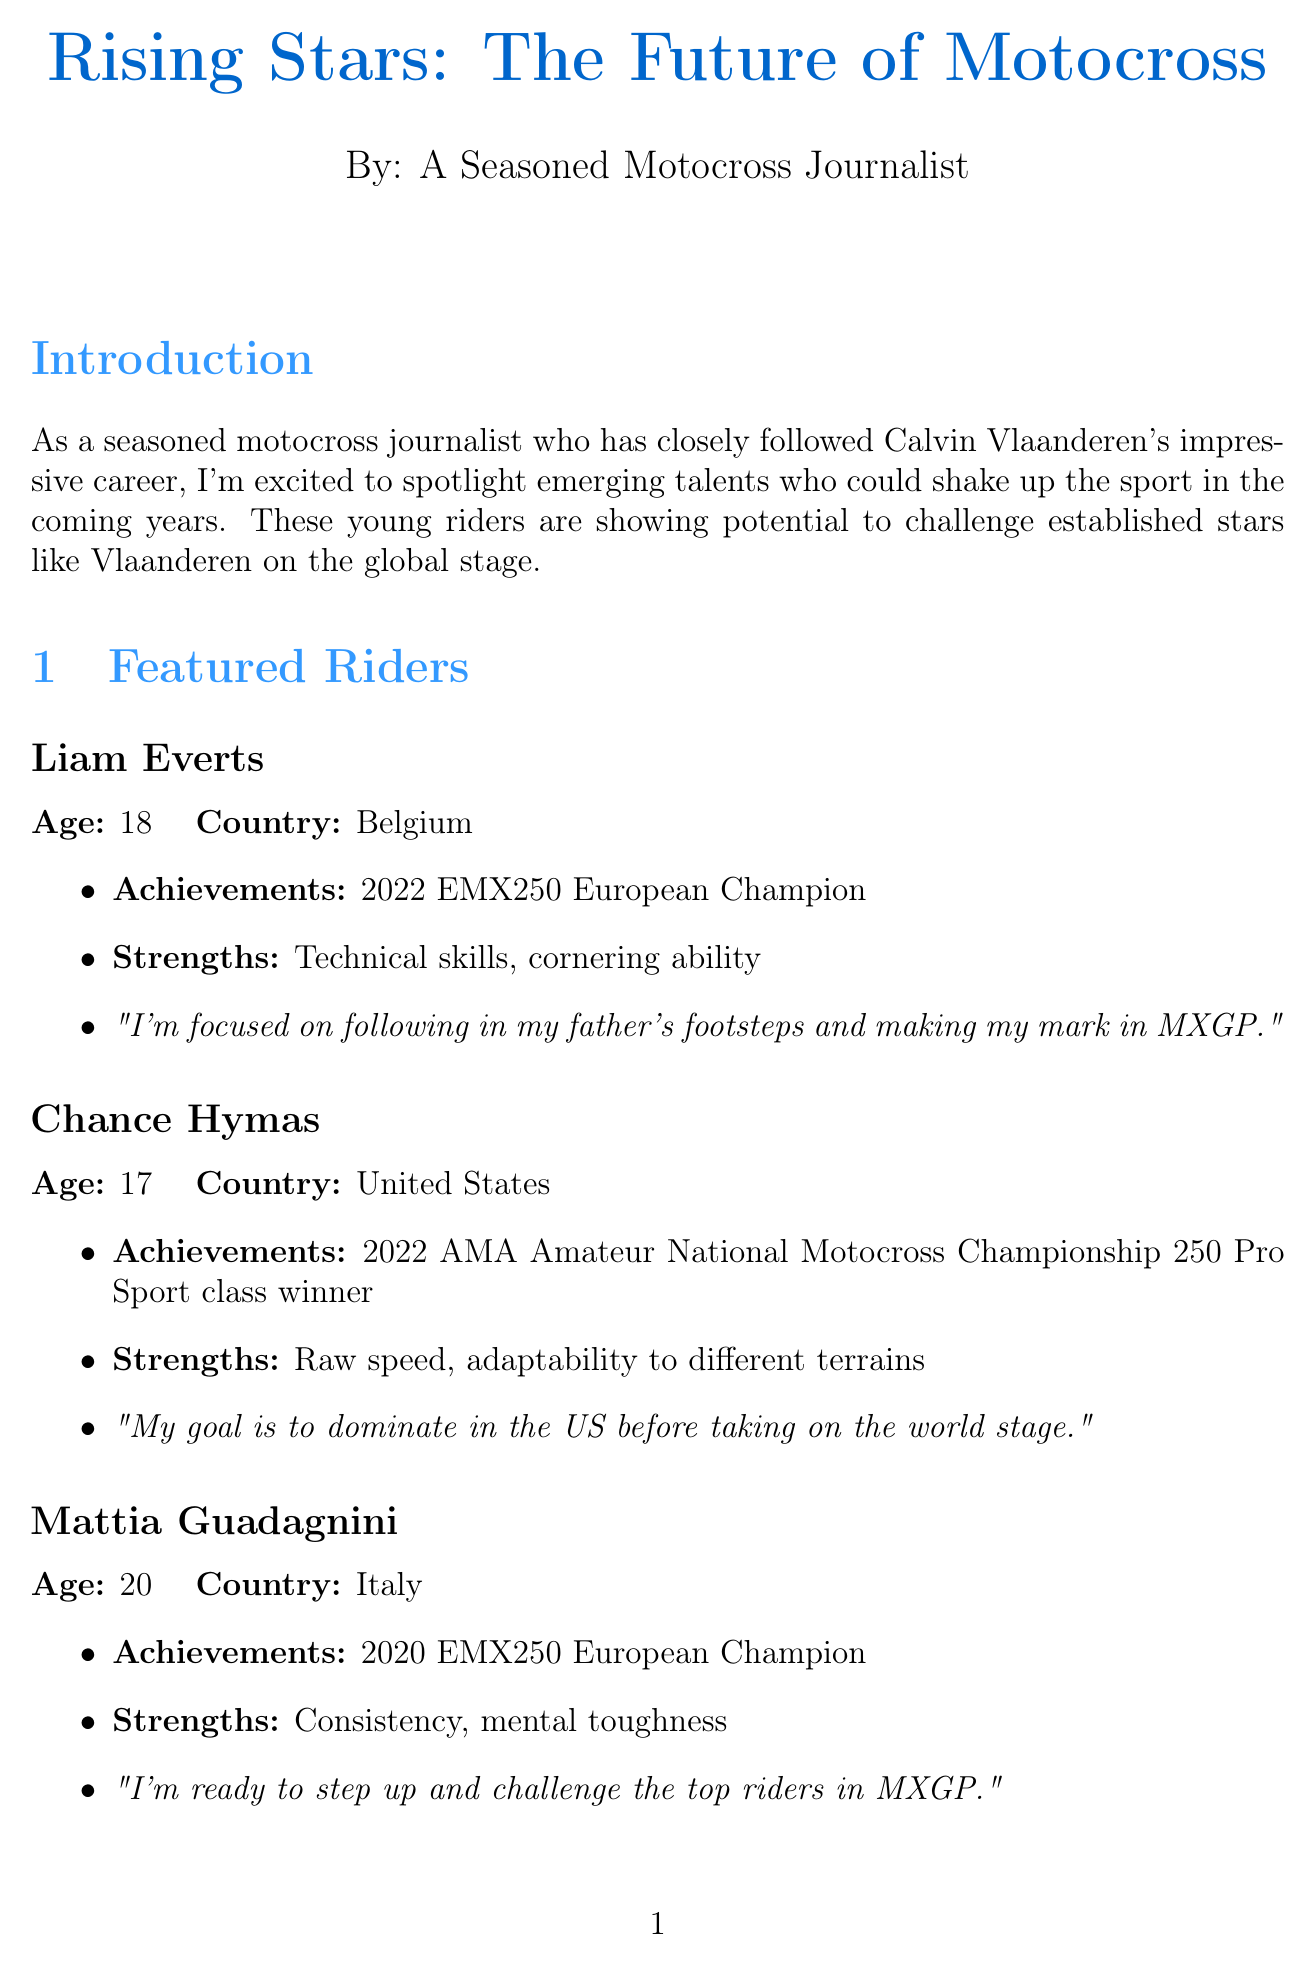What is the title of the newsletter? The title of the newsletter is clearly stated at the beginning of the document.
Answer: Rising Stars: The Future of Motocross Who is the featured rider from Belgium? The document lists several featured riders, and the one from Belgium is specified.
Answer: Liam Everts What age is Chance Hymas? Age is mentioned for each featured rider in the document.
Answer: 17 What was Mattia Guadagnini's achievement in 2020? The document highlights specific achievements for the featured riders.
Answer: 2020 EMX250 European Champion When does the MXGP of Patagonia-Argentina take place? The date for upcoming events is provided in the document.
Answer: March 12-13, 2023 What training innovation involves virtual reality? The document lists various training innovations that young riders are utilizing.
Answer: Virtual reality simulations for track familiarization What trend focuses on sustainability? Industry trends mentioned in the document highlight specific developments.
Answer: Increased focus on sustainability in bike manufacturing What advice does Calvin Vlaanderen give to young riders? The document includes a section with advice from Calvin Vlaanderen, which is a key quote.
Answer: Focus on consistency, stay humble, and always keep learning 